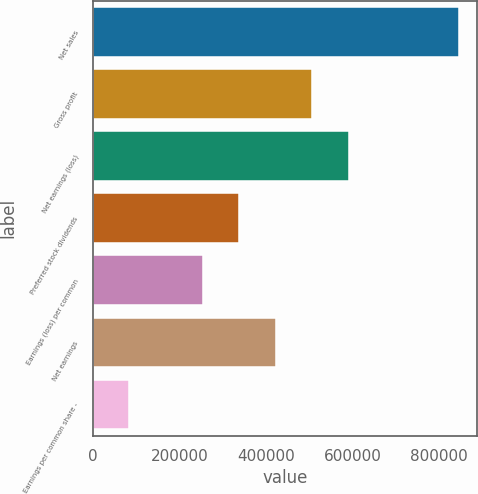<chart> <loc_0><loc_0><loc_500><loc_500><bar_chart><fcel>Net sales<fcel>Gross profit<fcel>Net earnings (loss)<fcel>Preferred stock dividends<fcel>Earnings (loss) per common<fcel>Net earnings<fcel>Earnings per common share -<nl><fcel>846071<fcel>507643<fcel>592250<fcel>338429<fcel>253822<fcel>423036<fcel>84607.4<nl></chart> 